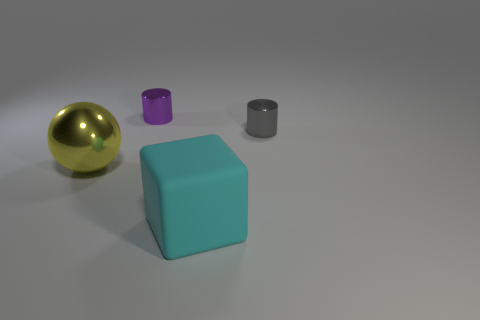Is the material of the cyan thing the same as the cylinder that is to the left of the cyan matte block?
Keep it short and to the point. No. Are there any purple cylinders in front of the purple metallic object?
Provide a succinct answer. No. How many objects are either green matte cubes or small purple metal cylinders that are on the left side of the tiny gray shiny cylinder?
Give a very brief answer. 1. The shiny thing that is in front of the tiny object right of the small purple metallic cylinder is what color?
Give a very brief answer. Yellow. How many other objects are the same material as the tiny gray cylinder?
Ensure brevity in your answer.  2. How many metal objects are balls or red cylinders?
Keep it short and to the point. 1. What color is the other tiny shiny thing that is the same shape as the purple shiny thing?
Your answer should be compact. Gray. What number of objects are red matte spheres or cyan things?
Your answer should be compact. 1. There is a large yellow object that is made of the same material as the small gray cylinder; what is its shape?
Offer a very short reply. Sphere. What number of tiny things are either brown metallic objects or gray cylinders?
Offer a terse response. 1. 